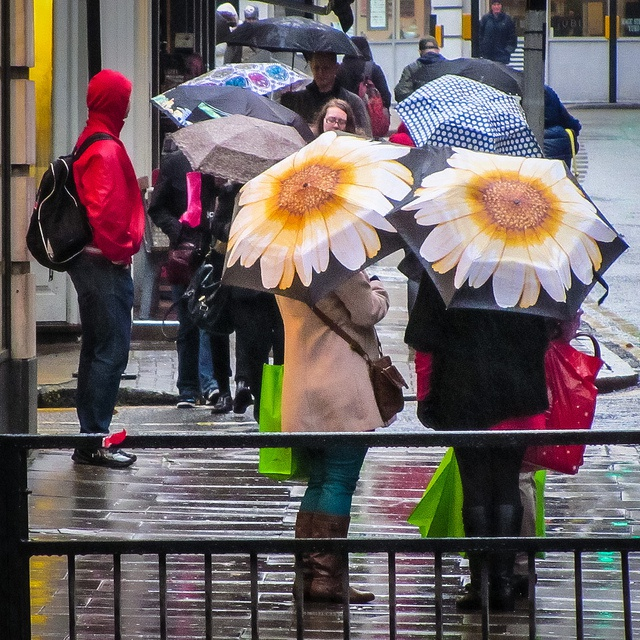Describe the objects in this image and their specific colors. I can see umbrella in gray, lightgray, tan, and darkgray tones, people in gray, black, maroon, and purple tones, umbrella in gray, lightgray, tan, and orange tones, people in gray, black, brown, and maroon tones, and people in gray, black, and darkgray tones in this image. 